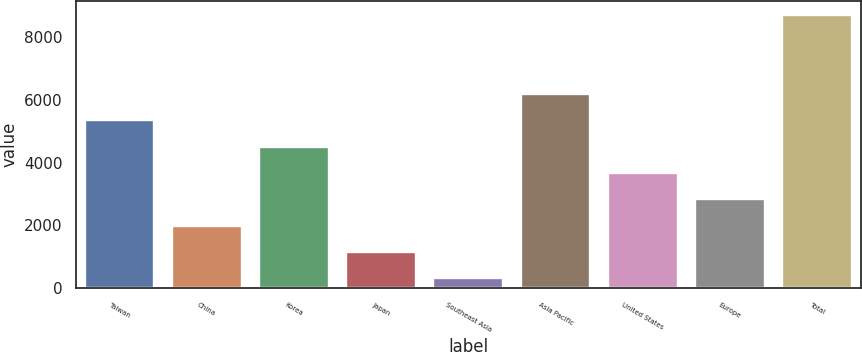<chart> <loc_0><loc_0><loc_500><loc_500><bar_chart><fcel>Taiwan<fcel>China<fcel>Korea<fcel>Japan<fcel>Southeast Asia<fcel>Asia Pacific<fcel>United States<fcel>Europe<fcel>Total<nl><fcel>5356.2<fcel>1993.4<fcel>4515.5<fcel>1152.7<fcel>312<fcel>6196.9<fcel>3674.8<fcel>2834.1<fcel>8719<nl></chart> 